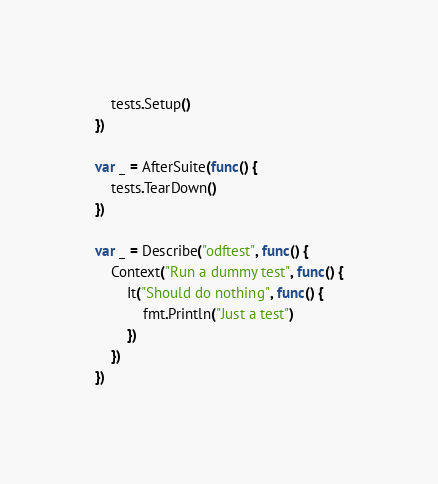<code> <loc_0><loc_0><loc_500><loc_500><_Go_>	tests.Setup()
})

var _ = AfterSuite(func() {
	tests.TearDown()
})

var _ = Describe("odftest", func() {
	Context("Run a dummy test", func() {
		It("Should do nothing", func() {
			fmt.Println("Just a test")
		})
	})
})
</code> 